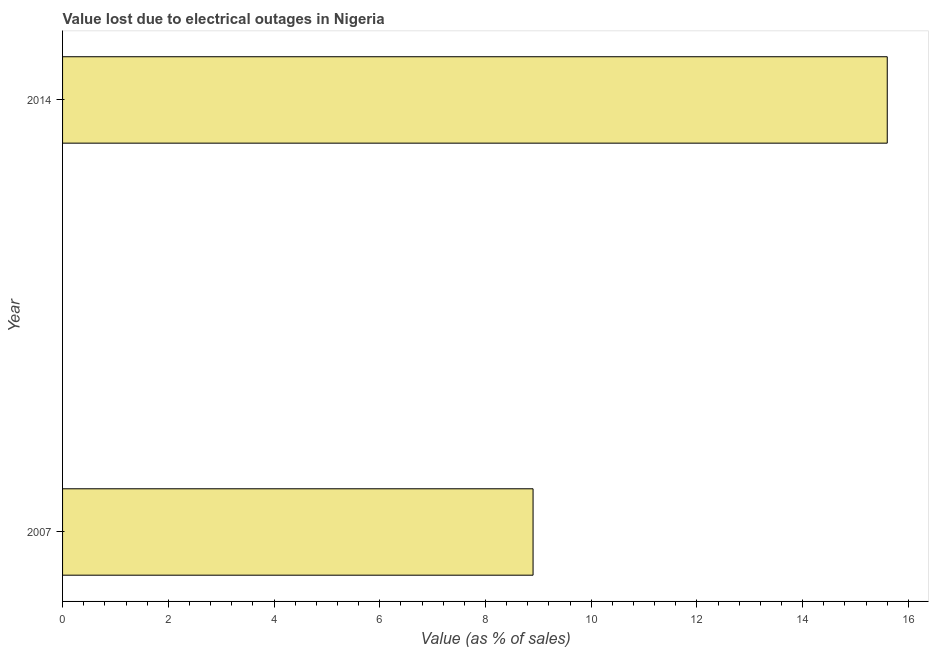Does the graph contain any zero values?
Your answer should be compact. No. What is the title of the graph?
Your response must be concise. Value lost due to electrical outages in Nigeria. What is the label or title of the X-axis?
Offer a terse response. Value (as % of sales). In which year was the value lost due to electrical outages maximum?
Ensure brevity in your answer.  2014. What is the sum of the value lost due to electrical outages?
Your answer should be compact. 24.5. What is the average value lost due to electrical outages per year?
Offer a terse response. 12.25. What is the median value lost due to electrical outages?
Keep it short and to the point. 12.25. In how many years, is the value lost due to electrical outages greater than 7.2 %?
Make the answer very short. 2. What is the ratio of the value lost due to electrical outages in 2007 to that in 2014?
Give a very brief answer. 0.57. Is the value lost due to electrical outages in 2007 less than that in 2014?
Provide a succinct answer. Yes. Are all the bars in the graph horizontal?
Provide a short and direct response. Yes. What is the difference between two consecutive major ticks on the X-axis?
Your answer should be very brief. 2. Are the values on the major ticks of X-axis written in scientific E-notation?
Provide a succinct answer. No. What is the ratio of the Value (as % of sales) in 2007 to that in 2014?
Your response must be concise. 0.57. 